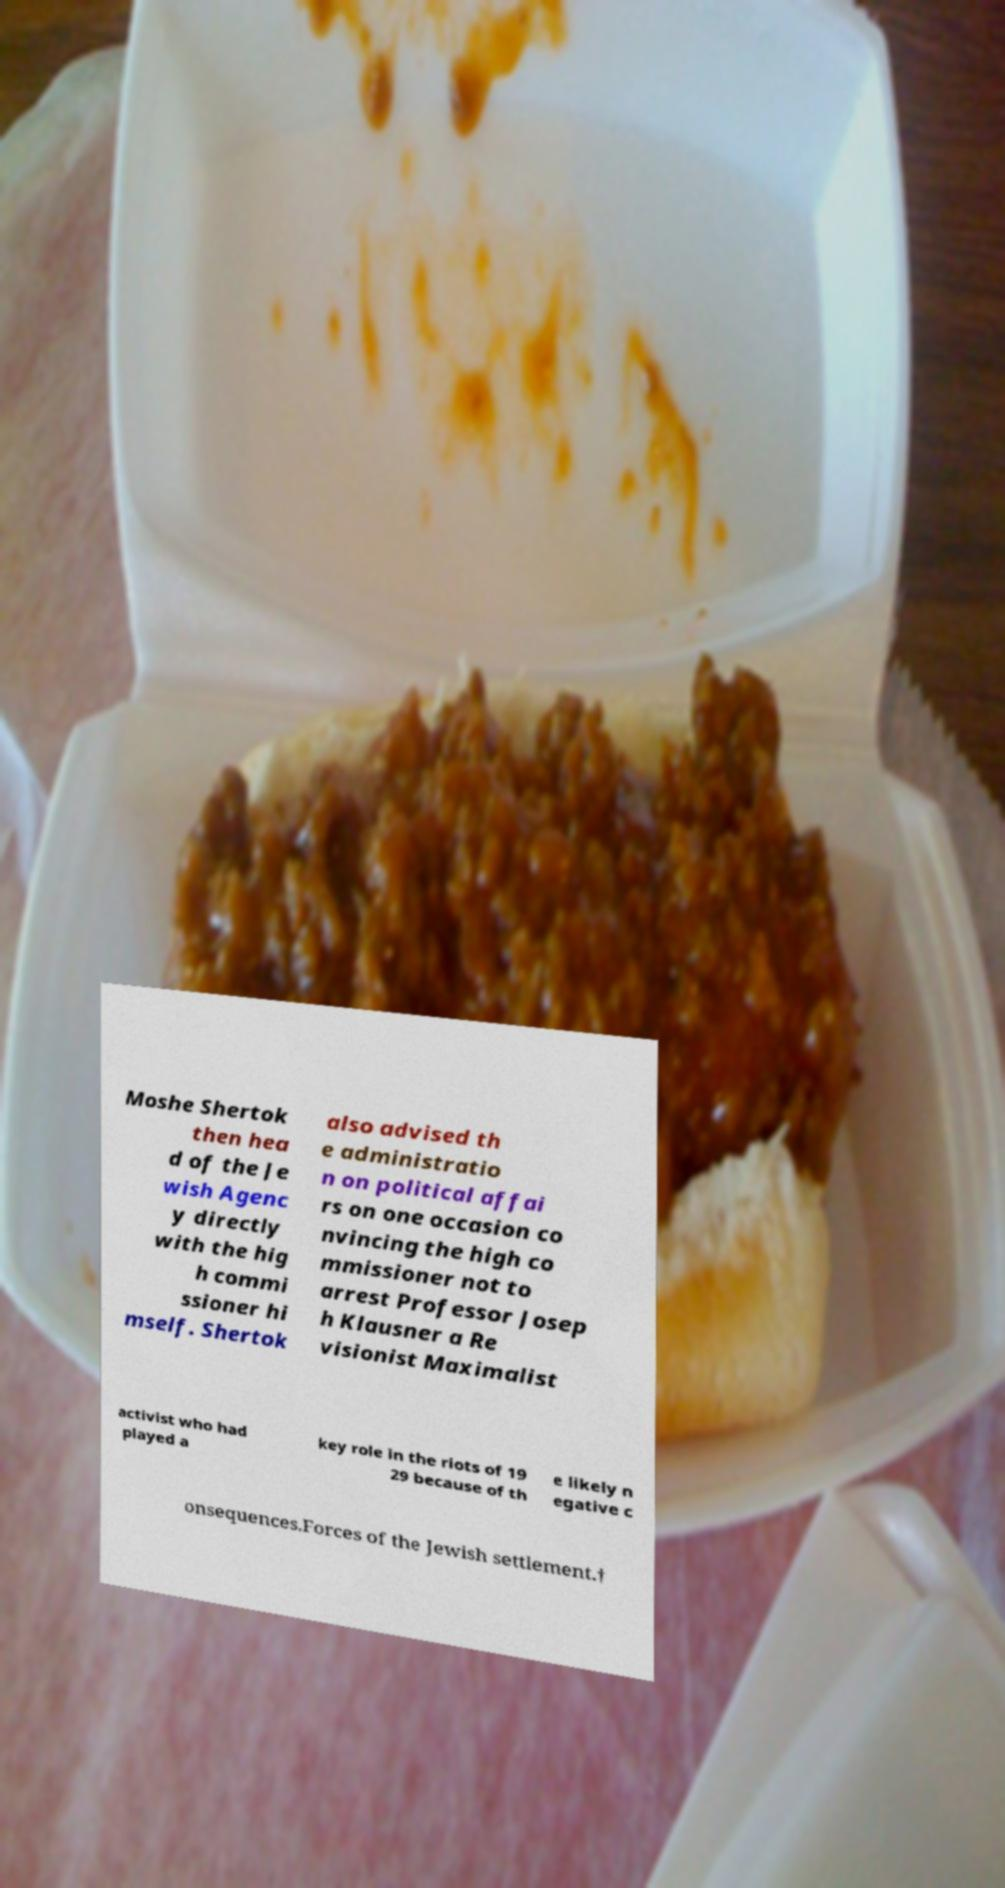For documentation purposes, I need the text within this image transcribed. Could you provide that? Moshe Shertok then hea d of the Je wish Agenc y directly with the hig h commi ssioner hi mself. Shertok also advised th e administratio n on political affai rs on one occasion co nvincing the high co mmissioner not to arrest Professor Josep h Klausner a Re visionist Maximalist activist who had played a key role in the riots of 19 29 because of th e likely n egative c onsequences.Forces of the Jewish settlement.† 